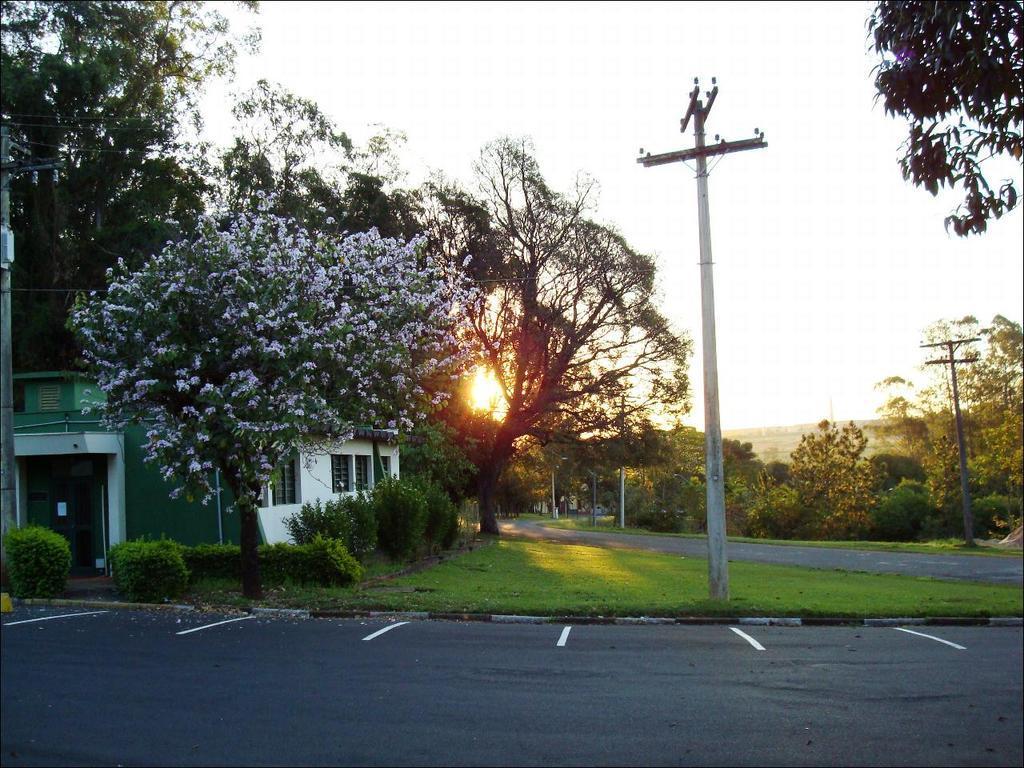Describe this image in one or two sentences. In this picture we can see the road and in the background we can see a house, electric poles, trees, sky. 